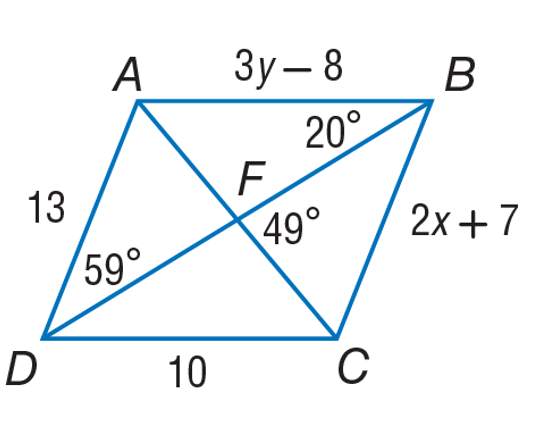Is parallelogram ABCD a rhombus? A rhombus is a type of parallelogram where all sides have equal length. In the image of parallelogram ABCD, side AB is equal to side CD, and side AD to side BC. However, we only see the numeric measurement for one side, which is CD with 10 units. Without knowing the lengths of AD and BC, we cannot definitively say it's a rhombus based on side lengths. If AD and BC are also 10 units, it would indeed be a rhombus. 